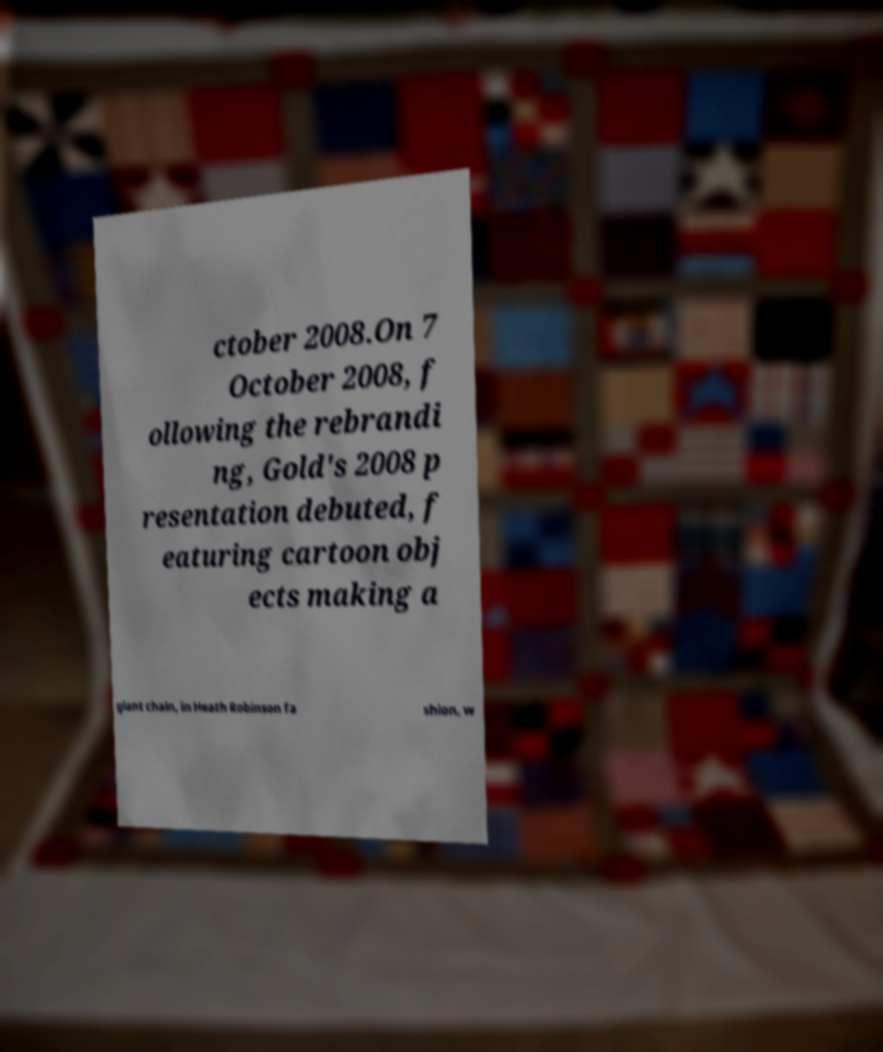Can you accurately transcribe the text from the provided image for me? ctober 2008.On 7 October 2008, f ollowing the rebrandi ng, Gold's 2008 p resentation debuted, f eaturing cartoon obj ects making a giant chain, in Heath Robinson fa shion, w 